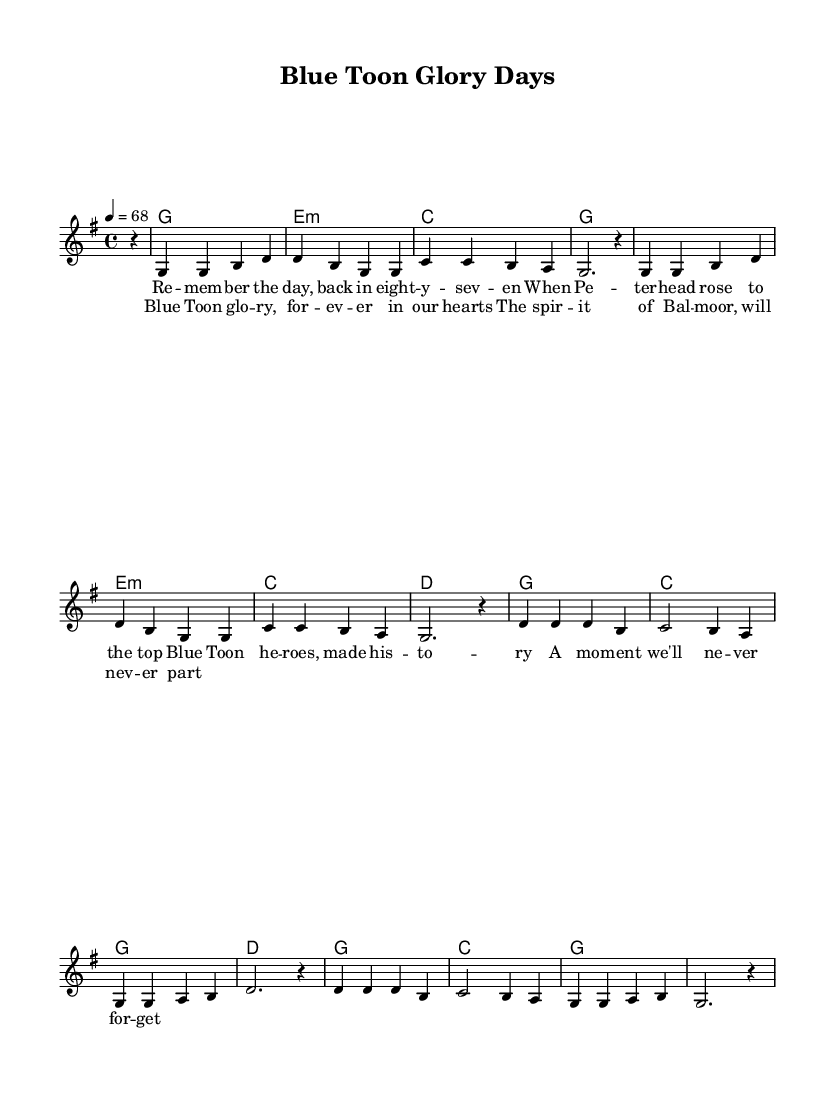What is the key signature of this music? The key signature is G major, indicated by one sharp (F#). It is found at the beginning of the sheet music before the time signature and sets the tonality for the piece.
Answer: G major What is the time signature of the music? The time signature is 4/4, which indicates that there are four beats in each measure and a quarter note receives one beat. This can be identified visually at the beginning of the piece right after the key signature.
Answer: 4/4 What is the tempo marking for the piece? The tempo marking is 4 = 68, meaning there are 68 beats per minute; this tells performers to play at a moderately slow pace. The tempo is specified just after the time signature on the first line of the header section.
Answer: 68 What are the lyrics for the chorus? The lyrics for the chorus are "Blue Toon glory, forever in our hearts, The spirit of Balmoral, will never part." These can be found beneath the respective melodic line in the sheet music where they align with the notes.
Answer: Blue Toon glory, forever in our hearts, The spirit of Balmoral, will never part How many bars are in the melody? The melody consists of 16 bars, which can be counted by dividing the music into measures as indicated by vertical lines in the sheet music, where each group of notes corresponds to one bar each.
Answer: 16 What genre do these songs belong to? The genre is soul, which emphasizes emotion and often recounts personal experiences or community stories. This is evident from the thematic focus on nostalgia and memorable moments in sports history reflected in the lyrics.
Answer: Soul 